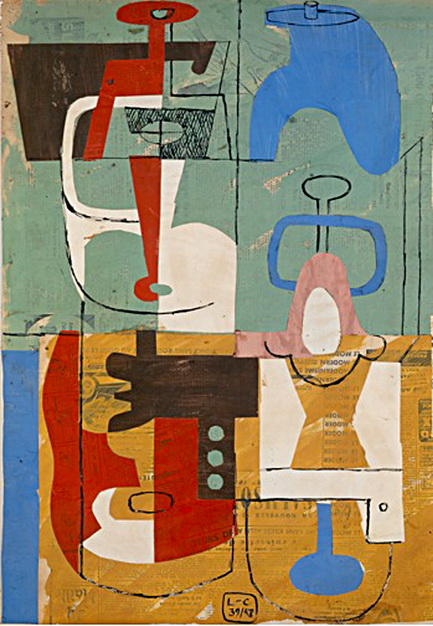Can you describe the main features of this image for me? The image depicts a complex abstract painting that utilizes a rich and varied palette, predominantly featuring tones of blue, red, orange, and white. These colors are arranged in geometric configurations reminiscent of the Cubist style, which often breaks down objects into abstract forms. Notably, the shapes include angular and curved forms that may evoke various interpretations, such as machinery parts, human faces, or abstract symbols. The piece’s layered composition, with its textured blue and green background, not only adds visual depth but also creates a subtle interplay between the vibrant foreground and the tranquil background, inviting viewers to delve into the imagery and explore personal connections or meanings. This artwork's visual narrative is built through its structural complexity and the dynamic balance of color and form, characteristic of mid-20th-century modernist expressions. 